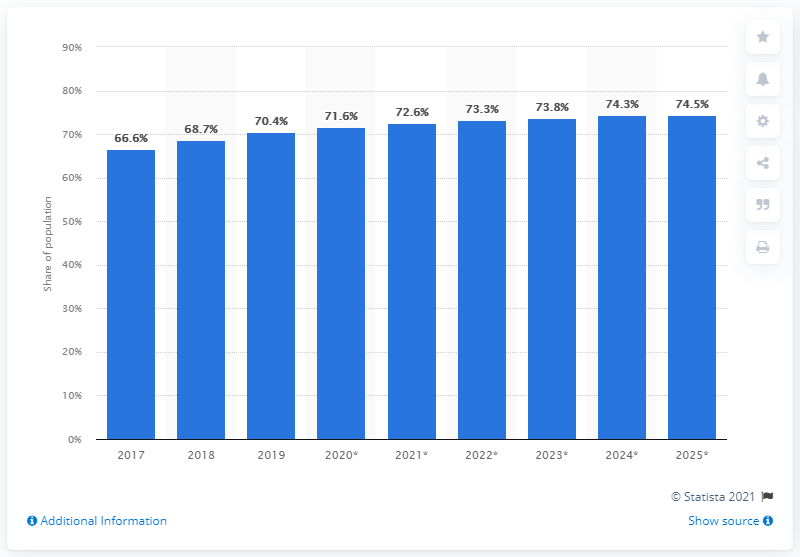List a handful of essential elements in this visual. By 2025, it is projected that 74.5% of Argentina's population will be using social networks. 